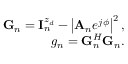<formula> <loc_0><loc_0><loc_500><loc_500>\begin{array} { r } { { G } _ { n } = { I } _ { n } ^ { z _ { d } } - \left | { { A } _ { n } } e ^ { j \phi } \right | ^ { 2 } , } \\ { g _ { n } = { G } _ { n } ^ { H } { G } _ { n } . } \end{array}</formula> 